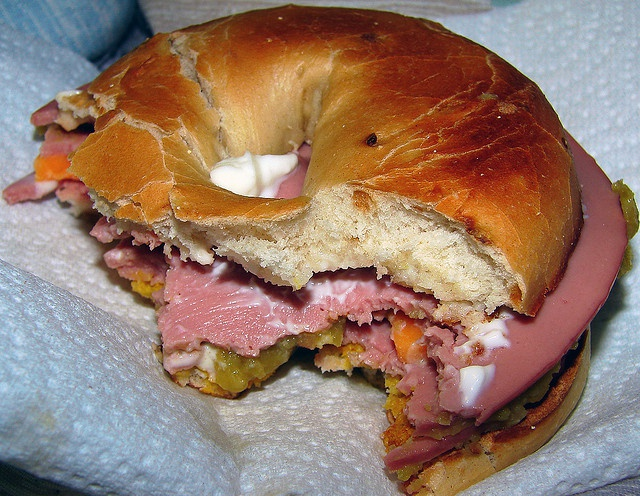Describe the objects in this image and their specific colors. I can see a sandwich in gray, brown, maroon, and tan tones in this image. 